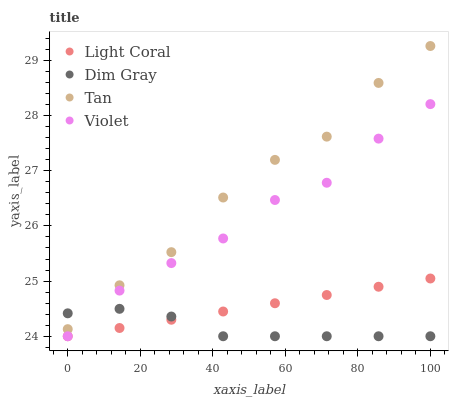Does Dim Gray have the minimum area under the curve?
Answer yes or no. Yes. Does Tan have the maximum area under the curve?
Answer yes or no. Yes. Does Tan have the minimum area under the curve?
Answer yes or no. No. Does Dim Gray have the maximum area under the curve?
Answer yes or no. No. Is Light Coral the smoothest?
Answer yes or no. Yes. Is Tan the roughest?
Answer yes or no. Yes. Is Dim Gray the smoothest?
Answer yes or no. No. Is Dim Gray the roughest?
Answer yes or no. No. Does Light Coral have the lowest value?
Answer yes or no. Yes. Does Tan have the lowest value?
Answer yes or no. No. Does Tan have the highest value?
Answer yes or no. Yes. Does Dim Gray have the highest value?
Answer yes or no. No. Is Violet less than Tan?
Answer yes or no. Yes. Is Tan greater than Light Coral?
Answer yes or no. Yes. Does Dim Gray intersect Tan?
Answer yes or no. Yes. Is Dim Gray less than Tan?
Answer yes or no. No. Is Dim Gray greater than Tan?
Answer yes or no. No. Does Violet intersect Tan?
Answer yes or no. No. 